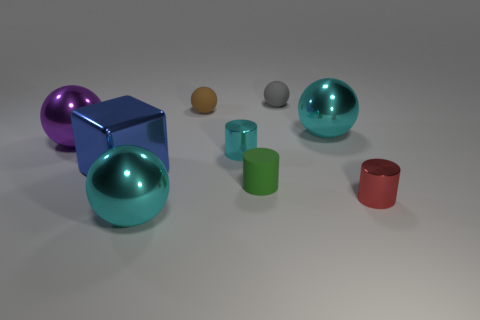How many metal objects are either cylinders or brown things?
Provide a short and direct response. 2. The sphere that is both left of the tiny brown rubber ball and to the right of the purple metallic object is what color?
Provide a short and direct response. Cyan. There is a ball in front of the red cylinder; is its size the same as the large blue block?
Offer a very short reply. Yes. What number of objects are either cylinders behind the small red metallic object or blocks?
Make the answer very short. 3. Is there a cylinder that has the same size as the brown thing?
Provide a short and direct response. Yes. There is a cyan thing that is the same size as the red metallic thing; what is it made of?
Make the answer very short. Metal. What is the shape of the metal object that is both to the right of the small cyan metallic cylinder and in front of the cube?
Offer a terse response. Cylinder. The metal object that is to the left of the cube is what color?
Provide a short and direct response. Purple. There is a metal thing that is both on the right side of the tiny gray ball and in front of the big purple sphere; what is its size?
Make the answer very short. Small. Do the block and the cylinder that is right of the tiny gray ball have the same material?
Provide a succinct answer. Yes. 